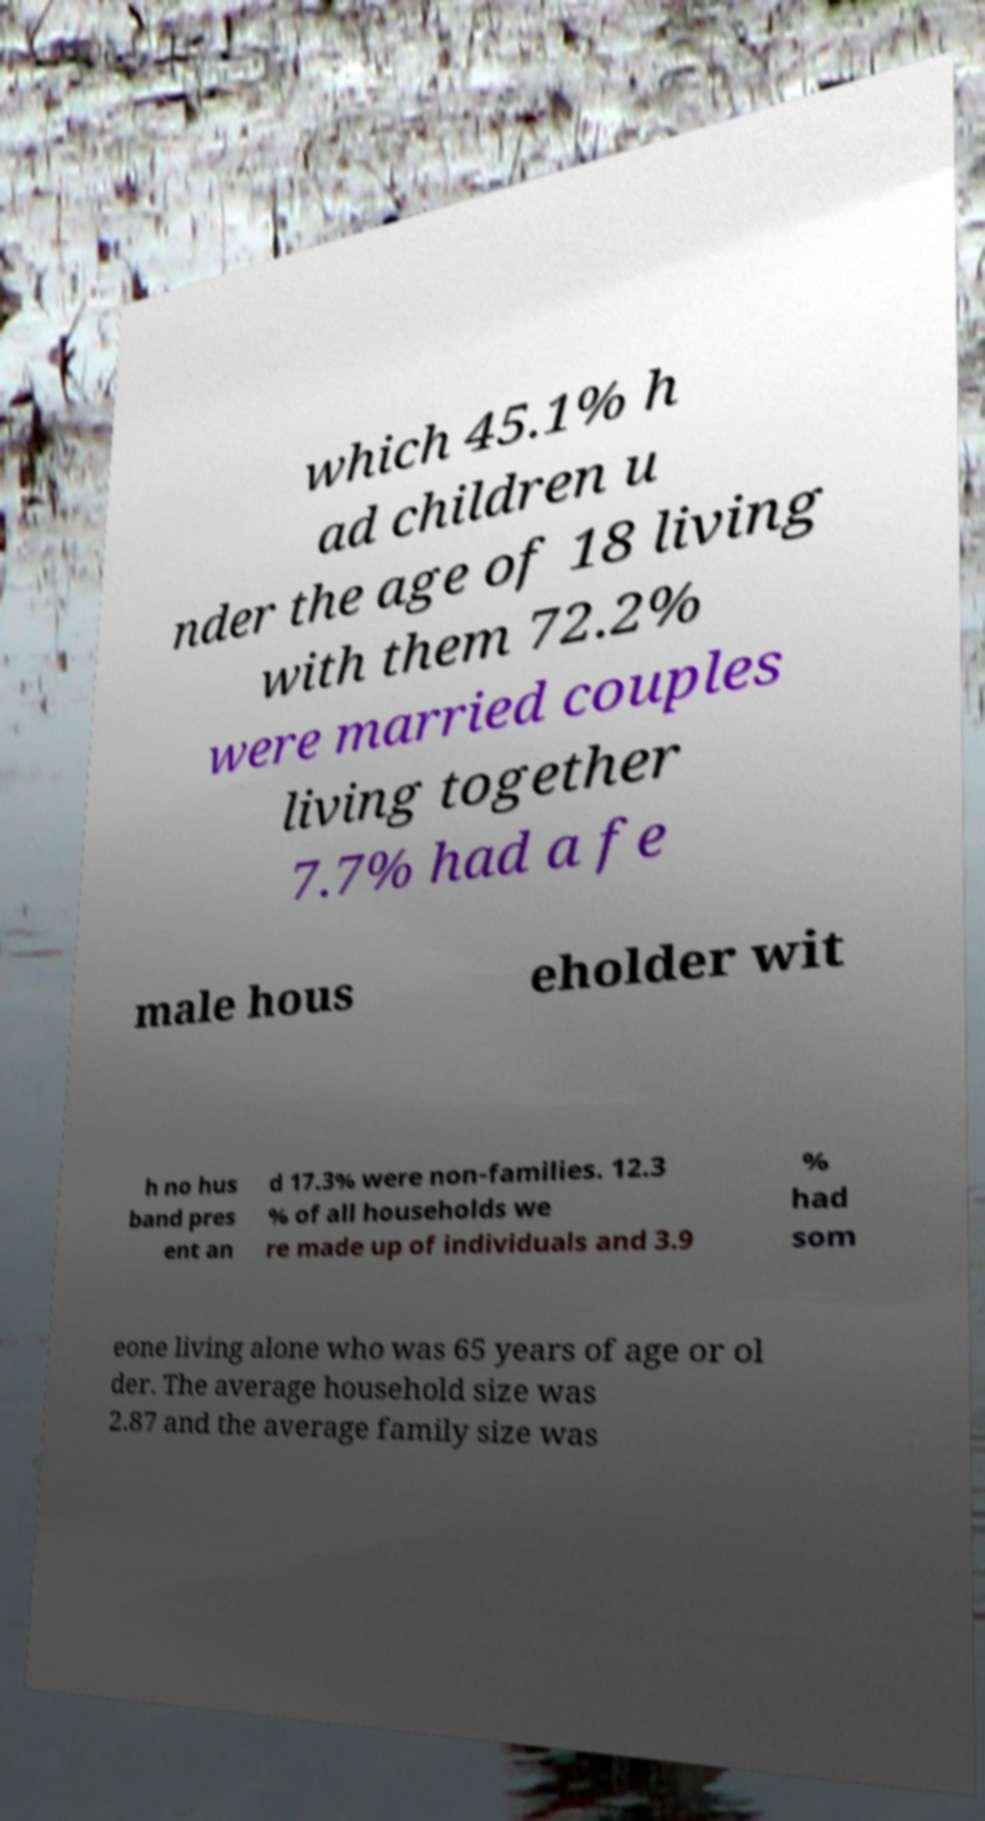Can you accurately transcribe the text from the provided image for me? which 45.1% h ad children u nder the age of 18 living with them 72.2% were married couples living together 7.7% had a fe male hous eholder wit h no hus band pres ent an d 17.3% were non-families. 12.3 % of all households we re made up of individuals and 3.9 % had som eone living alone who was 65 years of age or ol der. The average household size was 2.87 and the average family size was 